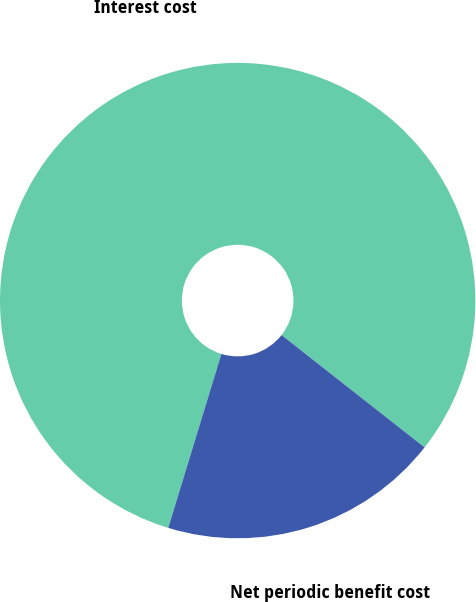Convert chart. <chart><loc_0><loc_0><loc_500><loc_500><pie_chart><fcel>Interest cost<fcel>Net periodic benefit cost<nl><fcel>80.88%<fcel>19.12%<nl></chart> 